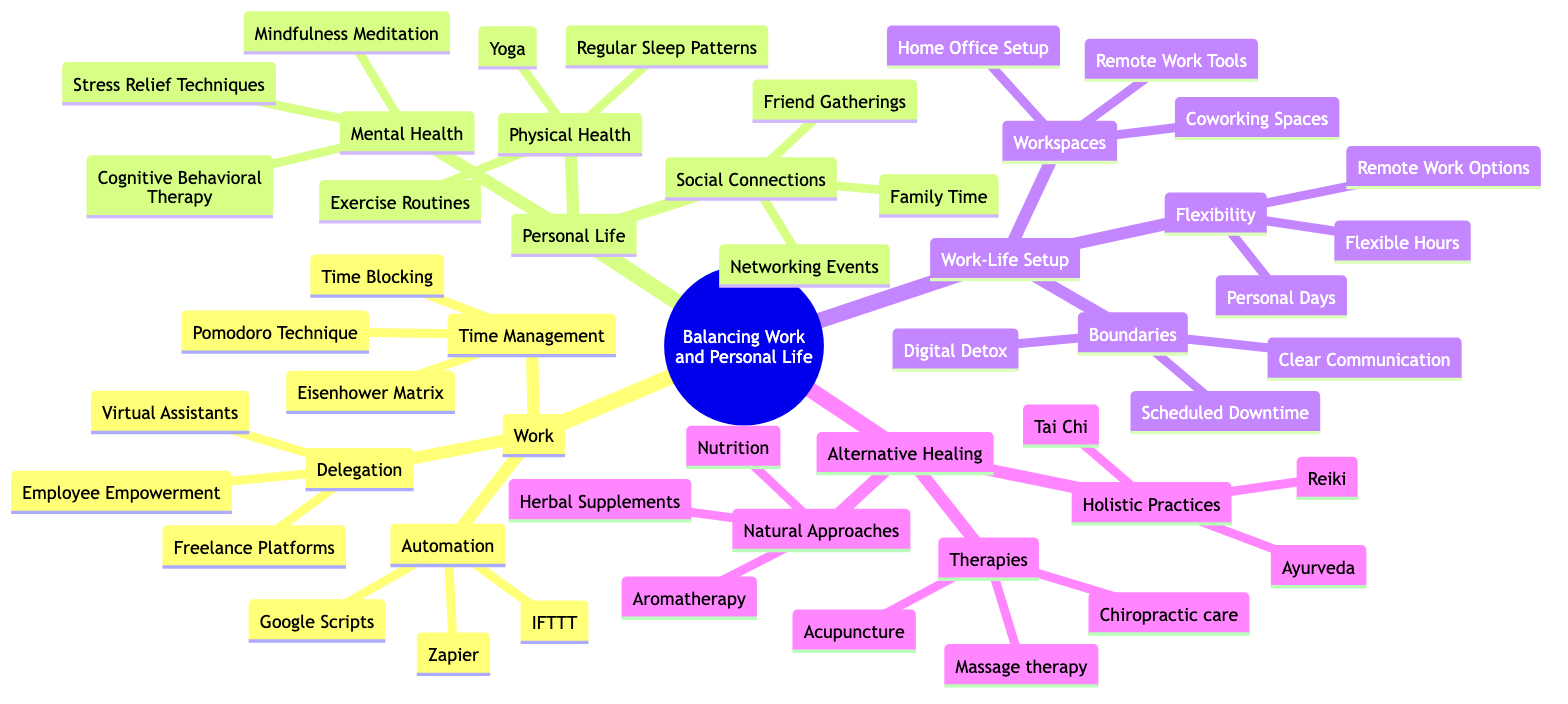What are the three main areas of focus in balancing work and personal life? The diagram lists three main areas: 'Work', 'Personal Life', and 'Work-Life Setup'. These areas encompass various strategies and practices for managing balance.
Answer: Work, Personal Life, Work-Life Setup How many techniques are listed under Time Management? Under the 'Time Management' section, there are three techniques: Pomodoro Technique, Eisenhower Matrix, and Time Blocking. Thus, the count is three.
Answer: 3 What types of natural approaches are suggested? The 'Natural Approaches' section includes three types: Herbal Supplements, Aromatherapy, and Nutrition. These are aimed at providing alternative healing options.
Answer: Herbal Supplements, Aromatherapy, Nutrition Which element is a part of both Mental Health and Physical Health sections? The 'Stress Relief Techniques' is part of the Mental Health section, while physical health practices are listed in practices such as Yoga and exercise routines; however, it directly indicates that stress management contributes to both categories.
Answer: Stress Relief Techniques What kind of workspaces are mentioned? The 'Workspaces' section mentions three types: Home Office Setup, Coworking Spaces, and Remote Work Tools, which help create an effective work environment.
Answer: Home Office Setup, Coworking Spaces, Remote Work Tools What is a method under Flexibility for improving work-life balance? The 'Flexibility' section includes various options, among which 'Flexible Hours' is a method highlighted to improve work-life balance.
Answer: Flexible Hours How many therapies are listed under Alternative Healing? There are three therapies indicated under the 'Therapies' section in Alternative Healing: Acupuncture, Chiropractic care, and Massage therapy. Therefore, the total is three.
Answer: 3 Which social connection activity is mentioned for personal life? The section on 'Social Connections' lists 'Family Time' as one of the activities, highlighting its importance for maintaining a balanced personal life.
Answer: Family Time What is a technique included in the Automation category? The 'Automation' section includes three techniques, one of which is 'Zapier', known for automating tasks.
Answer: Zapier 